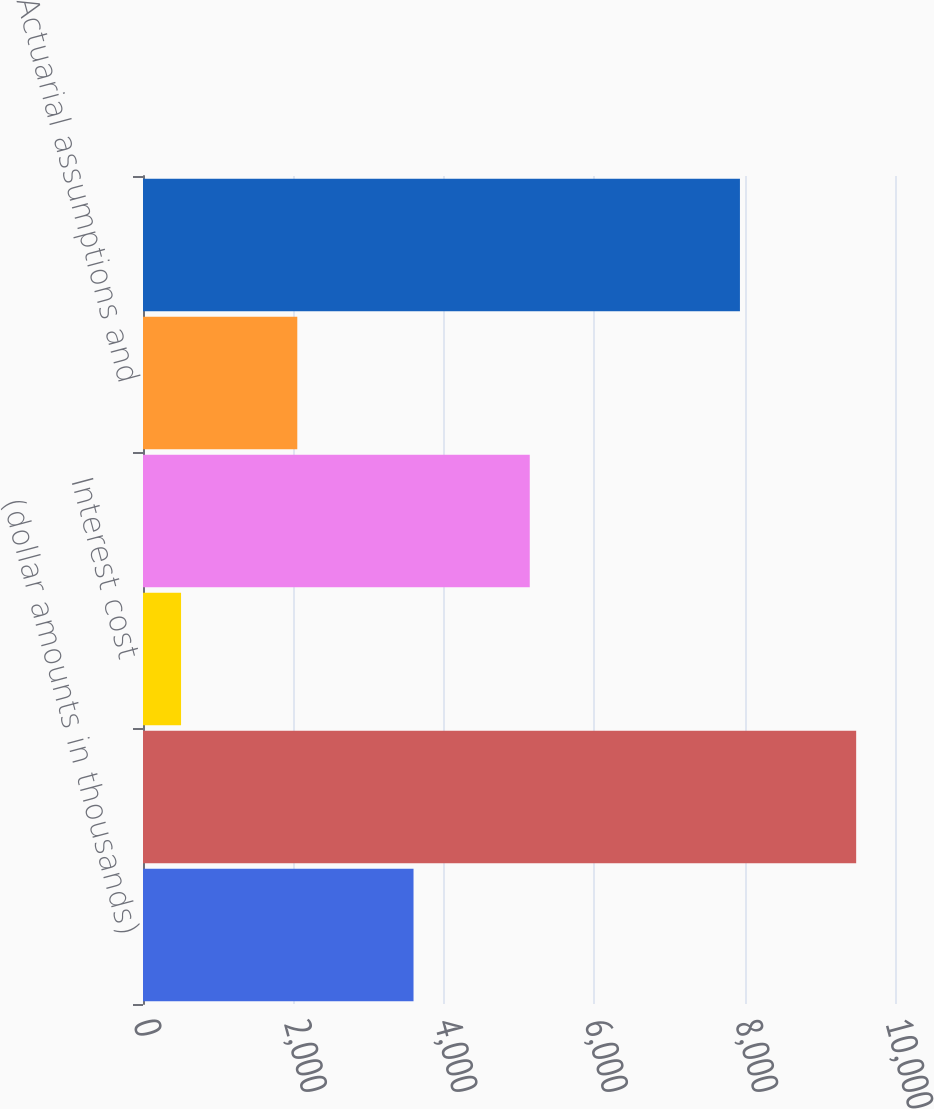Convert chart. <chart><loc_0><loc_0><loc_500><loc_500><bar_chart><fcel>(dollar amounts in thousands)<fcel>Projected benefit obligation<fcel>Interest cost<fcel>Benefits paid<fcel>Actuarial assumptions and<fcel>Total changes<nl><fcel>3597.4<fcel>9483.7<fcel>506<fcel>5143.1<fcel>2051.7<fcel>7938<nl></chart> 